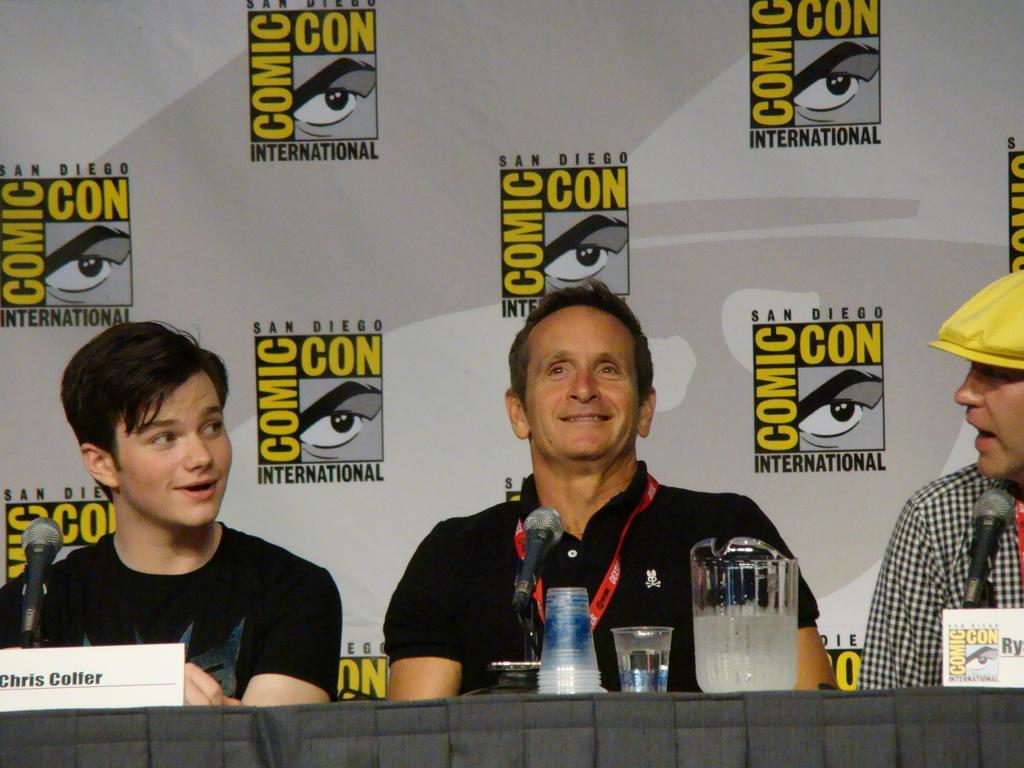Please provide a concise description of this image. In the picture we can see three men are sitting on the chairs near the desk, two men are in black T-shirts and one man is in shirt and cap and on the desk, we can see a jar with liquid in it and a glass beside it and behind them we can see a banner with some advertisement symbols on it. 